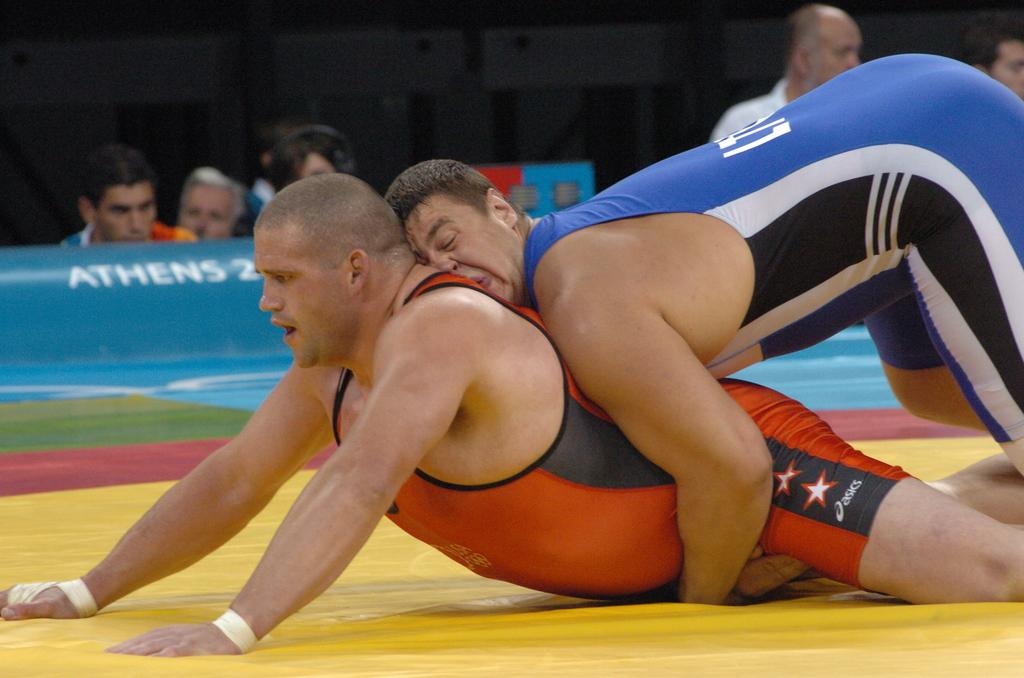<image>
Share a concise interpretation of the image provided. Wrestlers in an arena with the word Athens in the background. 